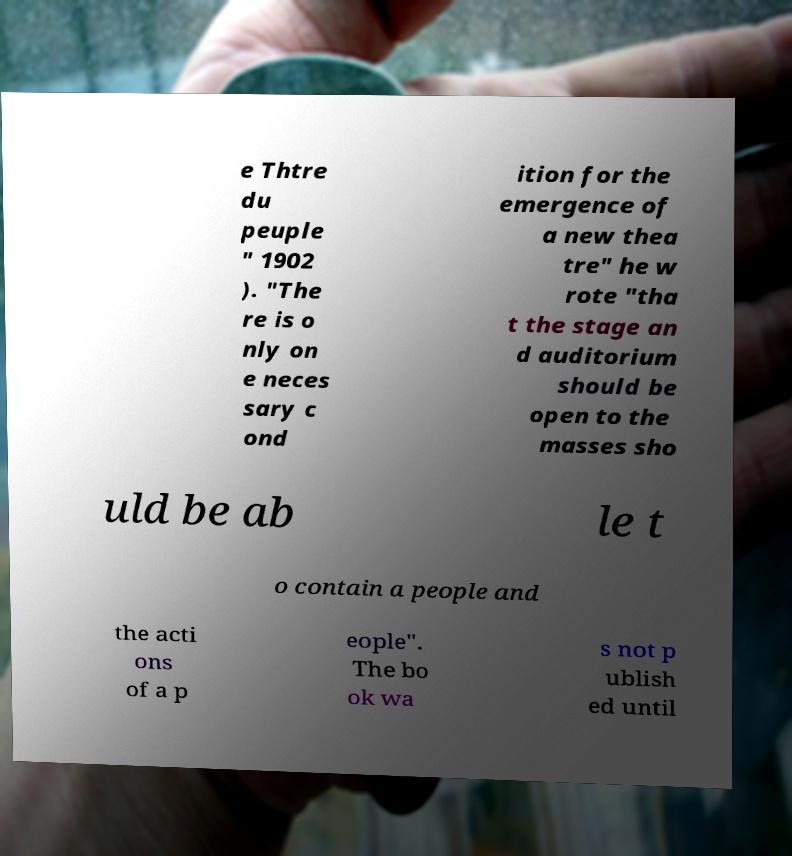There's text embedded in this image that I need extracted. Can you transcribe it verbatim? e Thtre du peuple " 1902 ). "The re is o nly on e neces sary c ond ition for the emergence of a new thea tre" he w rote "tha t the stage an d auditorium should be open to the masses sho uld be ab le t o contain a people and the acti ons of a p eople". The bo ok wa s not p ublish ed until 